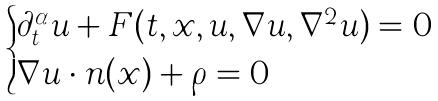Convert formula to latex. <formula><loc_0><loc_0><loc_500><loc_500>\begin{cases} \partial _ { t } ^ { \alpha } u + F ( t , x , u , \nabla u , \nabla ^ { 2 } u ) = 0 \quad & \\ \nabla u \cdot n ( x ) + \rho = 0 \quad & \end{cases}</formula> 